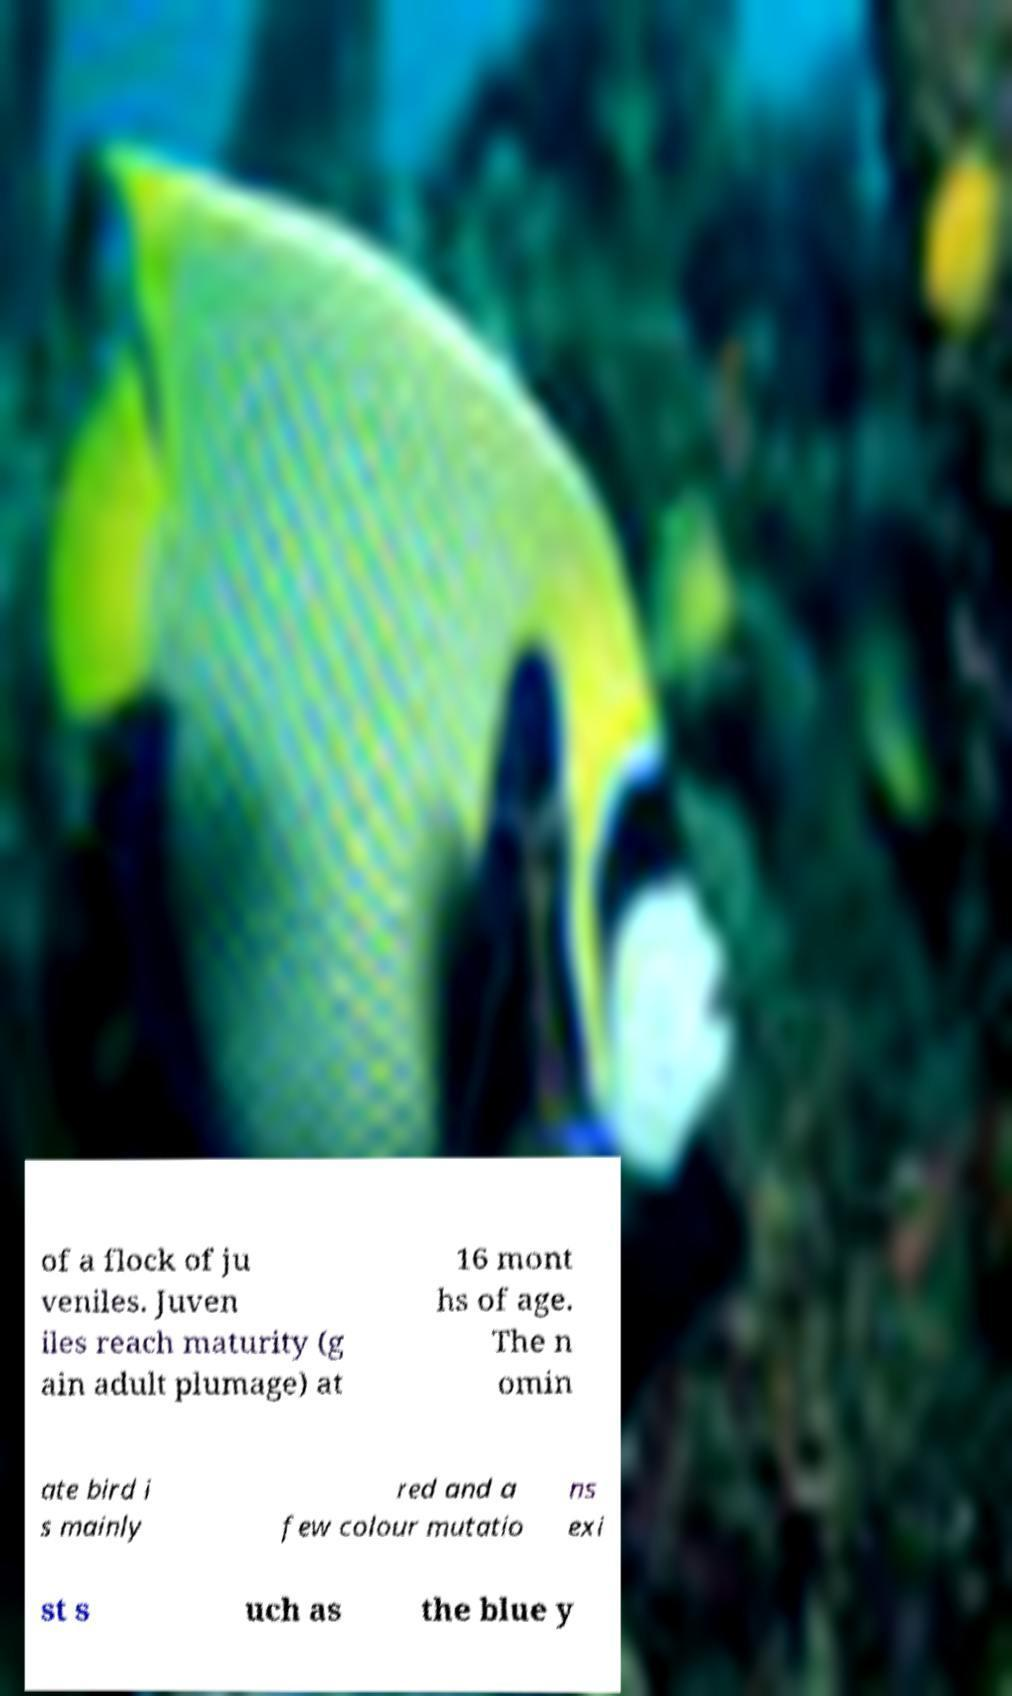Please identify and transcribe the text found in this image. of a flock of ju veniles. Juven iles reach maturity (g ain adult plumage) at 16 mont hs of age. The n omin ate bird i s mainly red and a few colour mutatio ns exi st s uch as the blue y 